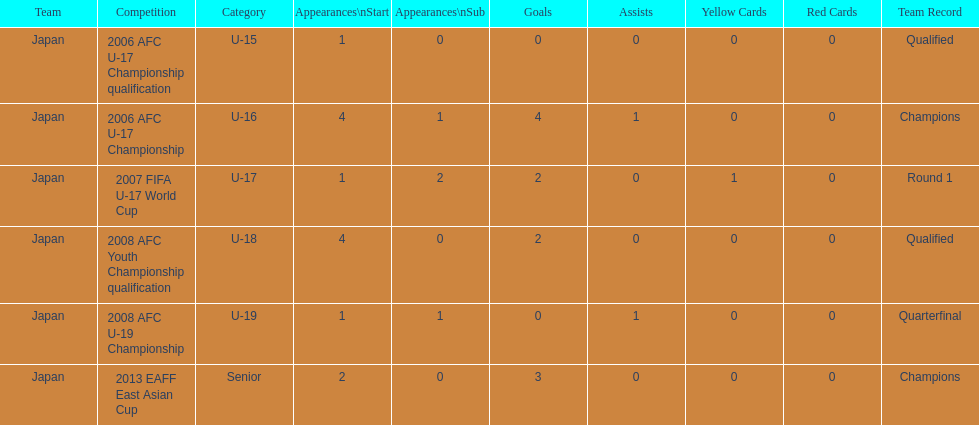In which tournament did japan have more opening appearances: the 2013 eaff east asian cup or the 2007 fifa u-17 world cup? 2013 EAFF East Asian Cup. 